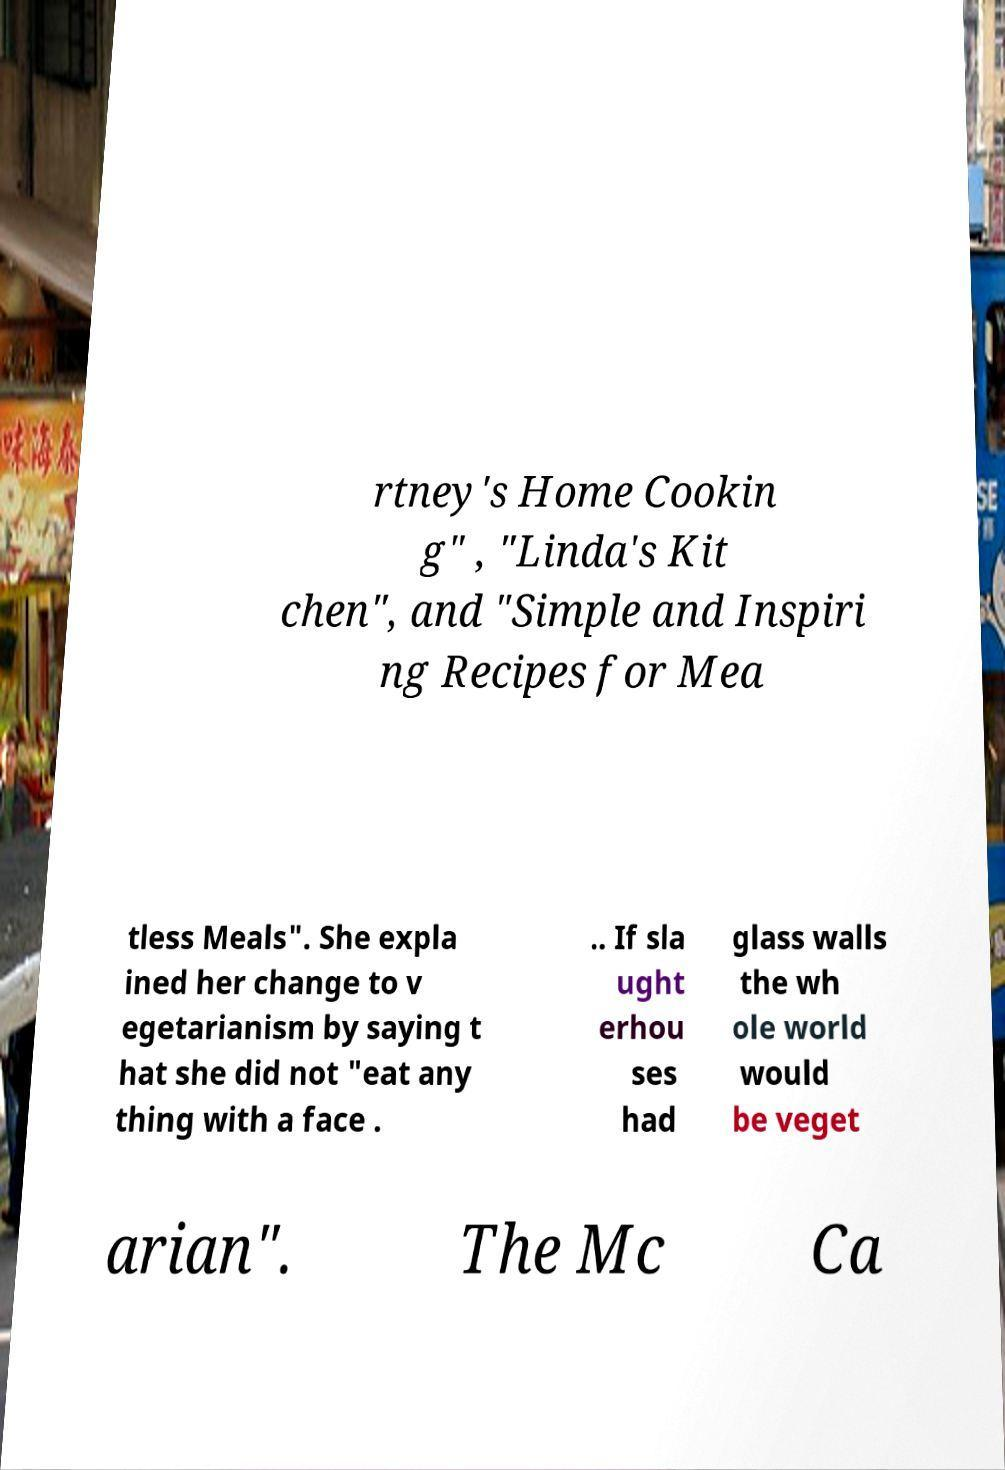Could you assist in decoding the text presented in this image and type it out clearly? rtney's Home Cookin g" , "Linda's Kit chen", and "Simple and Inspiri ng Recipes for Mea tless Meals". She expla ined her change to v egetarianism by saying t hat she did not "eat any thing with a face . .. If sla ught erhou ses had glass walls the wh ole world would be veget arian". The Mc Ca 